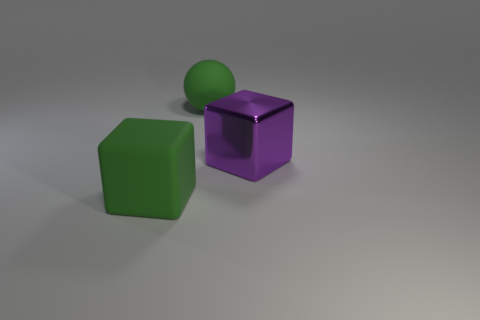How many large matte balls are in front of the shiny object?
Offer a very short reply. 0. Is the ball the same color as the metal cube?
Provide a short and direct response. No. What is the shape of the thing that is made of the same material as the green block?
Offer a terse response. Sphere. Does the large green thing that is in front of the big sphere have the same shape as the big metallic object?
Your answer should be compact. Yes. What number of green objects are either big cubes or big shiny cubes?
Offer a very short reply. 1. Are there the same number of green matte objects that are to the right of the green rubber ball and big purple shiny blocks on the left side of the purple block?
Provide a succinct answer. Yes. There is a thing right of the matte thing that is behind the large thing that is to the right of the green matte sphere; what color is it?
Your answer should be compact. Purple. Are there any other things of the same color as the big ball?
Offer a very short reply. Yes. There is a large matte object that is the same color as the matte cube; what is its shape?
Ensure brevity in your answer.  Sphere. There is a cube in front of the purple cube; what size is it?
Offer a very short reply. Large. 